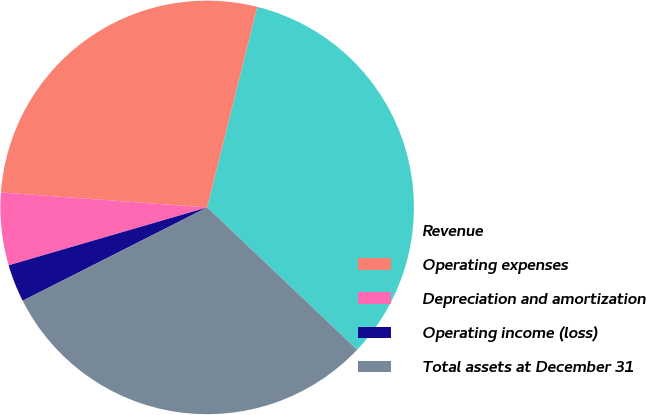Convert chart. <chart><loc_0><loc_0><loc_500><loc_500><pie_chart><fcel>Revenue<fcel>Operating expenses<fcel>Depreciation and amortization<fcel>Operating income (loss)<fcel>Total assets at December 31<nl><fcel>33.19%<fcel>27.74%<fcel>5.67%<fcel>2.94%<fcel>30.46%<nl></chart> 